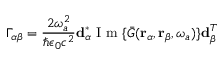<formula> <loc_0><loc_0><loc_500><loc_500>\Gamma _ { \alpha \beta } = \frac { 2 \omega _ { a } ^ { 2 } } { \hbar { \epsilon } _ { 0 } c ^ { 2 } } d _ { \alpha } ^ { * } I m \{ \bar { G } ( r _ { \alpha } , r _ { \beta } , \omega _ { a } ) \} d _ { \beta } ^ { T }</formula> 